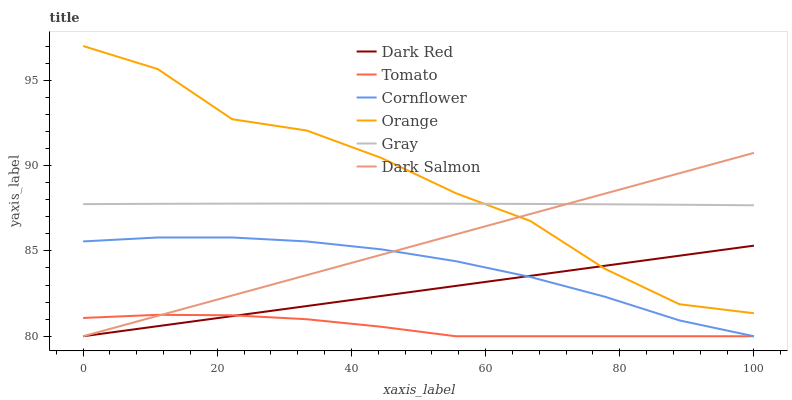Does Tomato have the minimum area under the curve?
Answer yes or no. Yes. Does Orange have the maximum area under the curve?
Answer yes or no. Yes. Does Gray have the minimum area under the curve?
Answer yes or no. No. Does Gray have the maximum area under the curve?
Answer yes or no. No. Is Dark Red the smoothest?
Answer yes or no. Yes. Is Orange the roughest?
Answer yes or no. Yes. Is Gray the smoothest?
Answer yes or no. No. Is Gray the roughest?
Answer yes or no. No. Does Tomato have the lowest value?
Answer yes or no. Yes. Does Gray have the lowest value?
Answer yes or no. No. Does Orange have the highest value?
Answer yes or no. Yes. Does Gray have the highest value?
Answer yes or no. No. Is Dark Red less than Gray?
Answer yes or no. Yes. Is Gray greater than Tomato?
Answer yes or no. Yes. Does Dark Salmon intersect Tomato?
Answer yes or no. Yes. Is Dark Salmon less than Tomato?
Answer yes or no. No. Is Dark Salmon greater than Tomato?
Answer yes or no. No. Does Dark Red intersect Gray?
Answer yes or no. No. 